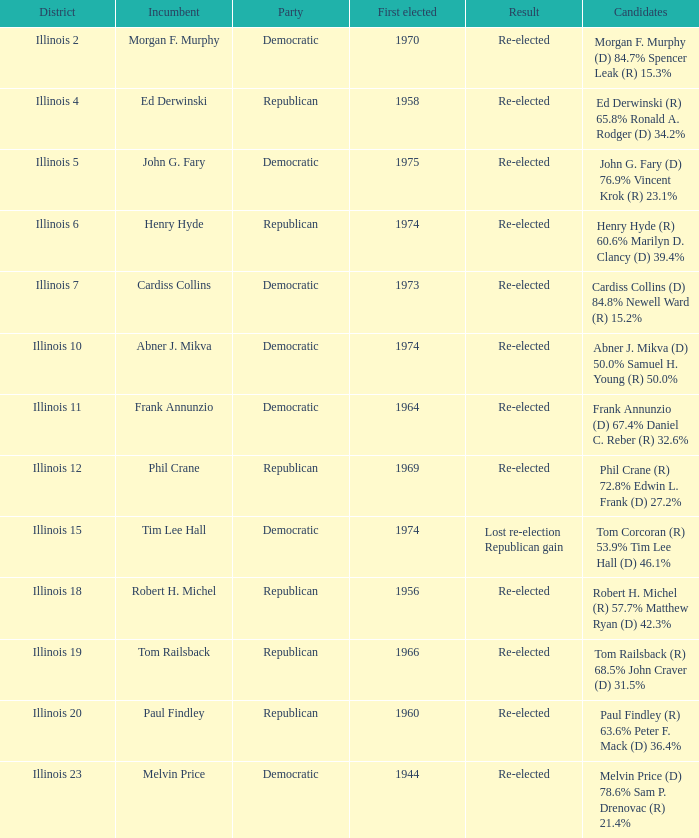Who are the applicants for illinois 15? Tom Corcoran (R) 53.9% Tim Lee Hall (D) 46.1%. 